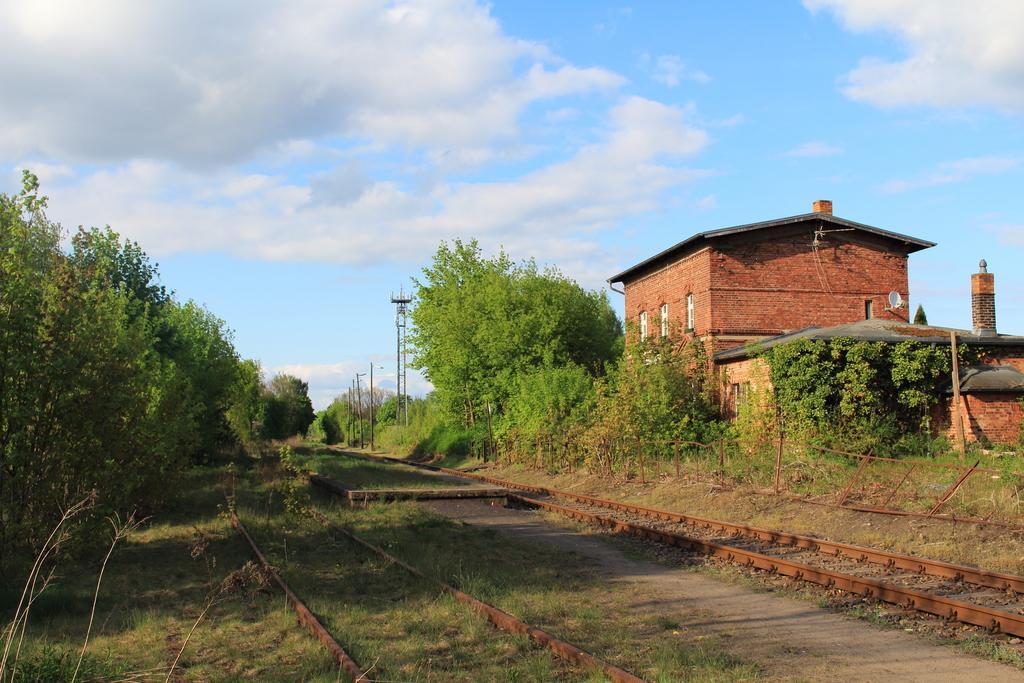In one or two sentences, can you explain what this image depicts? In this image there is sky, there are clouds in the sky, there are treeś, there is a tower, there are poles, there is grass, there is a railway track, there is a fencing, there is a house. 